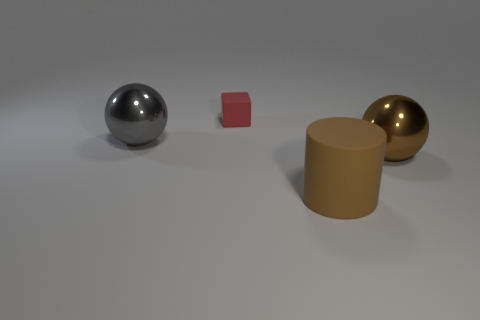How many objects are in the image, and can you describe their shapes? There are four objects in the image: one is a sphere, another is a cube, the third is a cylinder, and the last is another sphere. The spheres appear smooth, the cube has sharp edges, and the cylinder has one flat face and one curved surface. 